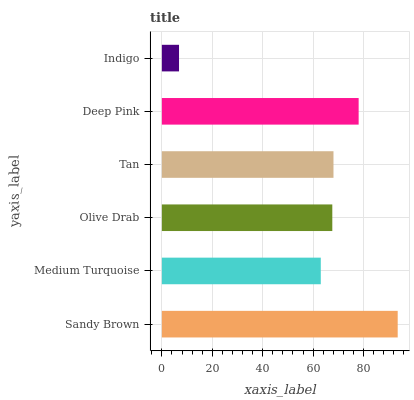Is Indigo the minimum?
Answer yes or no. Yes. Is Sandy Brown the maximum?
Answer yes or no. Yes. Is Medium Turquoise the minimum?
Answer yes or no. No. Is Medium Turquoise the maximum?
Answer yes or no. No. Is Sandy Brown greater than Medium Turquoise?
Answer yes or no. Yes. Is Medium Turquoise less than Sandy Brown?
Answer yes or no. Yes. Is Medium Turquoise greater than Sandy Brown?
Answer yes or no. No. Is Sandy Brown less than Medium Turquoise?
Answer yes or no. No. Is Tan the high median?
Answer yes or no. Yes. Is Olive Drab the low median?
Answer yes or no. Yes. Is Sandy Brown the high median?
Answer yes or no. No. Is Deep Pink the low median?
Answer yes or no. No. 